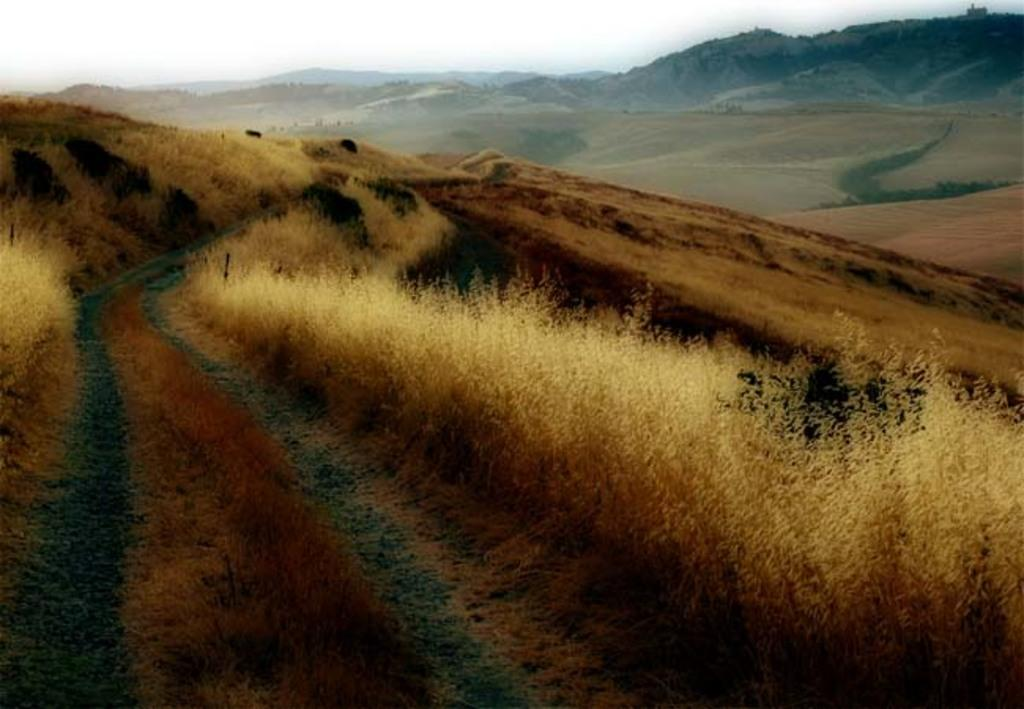What type of landscape can be seen in the image? There are hills in the image. What type of vegetation is present in the image? There is grass in the image. What is visible at the top of the image? The sky is visible at the top of the image. How much money is needed to purchase the hills in the image? The image does not provide any information about the cost or ownership of the hills, so it is impossible to determine how much money would be needed to purchase them. 